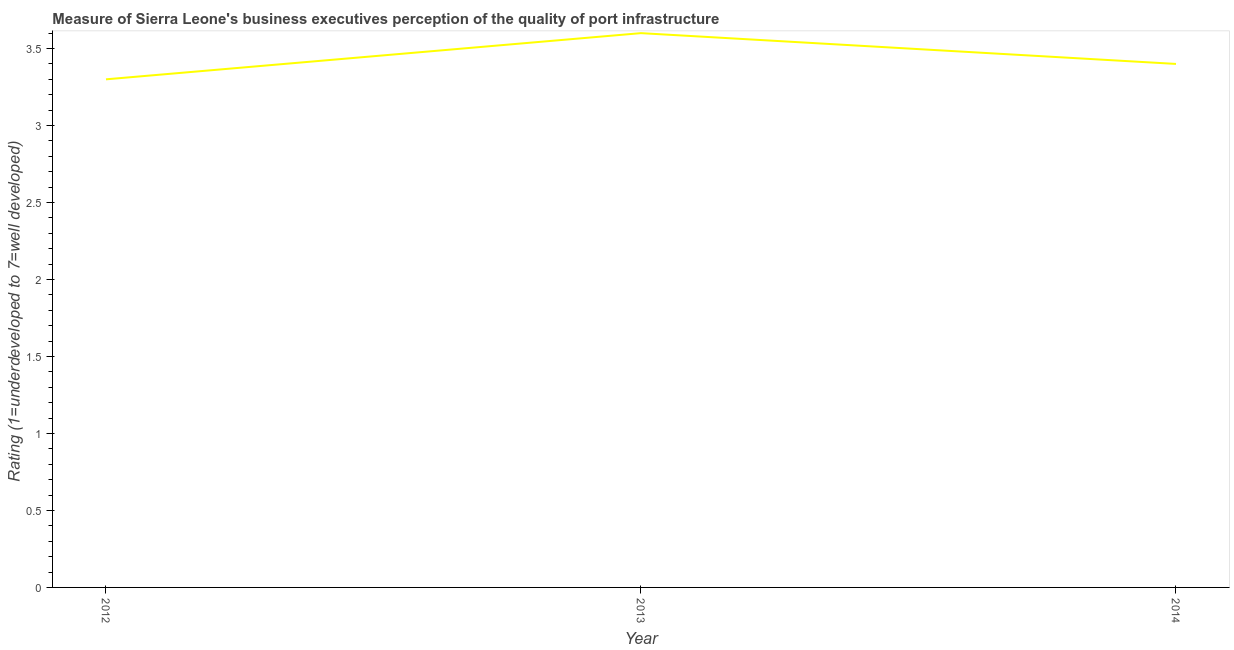What is the rating measuring quality of port infrastructure in 2013?
Make the answer very short. 3.6. Across all years, what is the maximum rating measuring quality of port infrastructure?
Your answer should be very brief. 3.6. In which year was the rating measuring quality of port infrastructure maximum?
Offer a terse response. 2013. What is the difference between the rating measuring quality of port infrastructure in 2013 and 2014?
Your response must be concise. 0.2. What is the average rating measuring quality of port infrastructure per year?
Make the answer very short. 3.43. What is the median rating measuring quality of port infrastructure?
Provide a succinct answer. 3.4. What is the ratio of the rating measuring quality of port infrastructure in 2013 to that in 2014?
Provide a short and direct response. 1.06. Is the rating measuring quality of port infrastructure in 2013 less than that in 2014?
Provide a short and direct response. No. Is the difference between the rating measuring quality of port infrastructure in 2012 and 2014 greater than the difference between any two years?
Offer a very short reply. No. What is the difference between the highest and the second highest rating measuring quality of port infrastructure?
Your response must be concise. 0.2. Is the sum of the rating measuring quality of port infrastructure in 2012 and 2013 greater than the maximum rating measuring quality of port infrastructure across all years?
Your answer should be very brief. Yes. What is the difference between the highest and the lowest rating measuring quality of port infrastructure?
Provide a short and direct response. 0.3. In how many years, is the rating measuring quality of port infrastructure greater than the average rating measuring quality of port infrastructure taken over all years?
Ensure brevity in your answer.  1. What is the difference between two consecutive major ticks on the Y-axis?
Provide a succinct answer. 0.5. Are the values on the major ticks of Y-axis written in scientific E-notation?
Your response must be concise. No. Does the graph contain any zero values?
Your response must be concise. No. What is the title of the graph?
Your response must be concise. Measure of Sierra Leone's business executives perception of the quality of port infrastructure. What is the label or title of the Y-axis?
Your answer should be compact. Rating (1=underdeveloped to 7=well developed) . What is the ratio of the Rating (1=underdeveloped to 7=well developed)  in 2012 to that in 2013?
Offer a very short reply. 0.92. What is the ratio of the Rating (1=underdeveloped to 7=well developed)  in 2013 to that in 2014?
Make the answer very short. 1.06. 